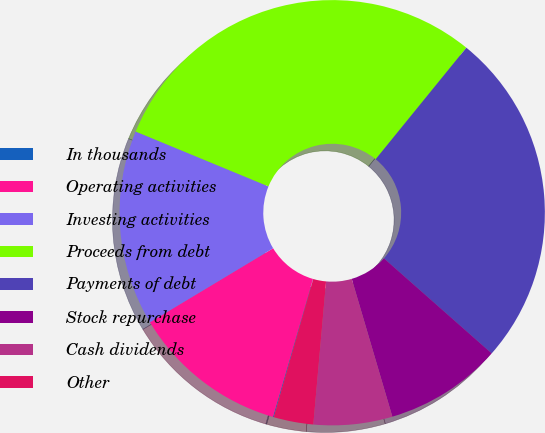Convert chart to OTSL. <chart><loc_0><loc_0><loc_500><loc_500><pie_chart><fcel>In thousands<fcel>Operating activities<fcel>Investing activities<fcel>Proceeds from debt<fcel>Payments of debt<fcel>Stock repurchase<fcel>Cash dividends<fcel>Other<nl><fcel>0.06%<fcel>11.89%<fcel>14.85%<fcel>29.63%<fcel>25.64%<fcel>8.93%<fcel>5.98%<fcel>3.02%<nl></chart> 